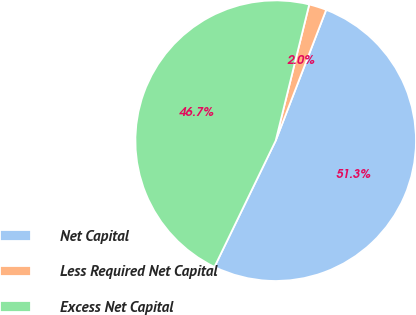Convert chart to OTSL. <chart><loc_0><loc_0><loc_500><loc_500><pie_chart><fcel>Net Capital<fcel>Less Required Net Capital<fcel>Excess Net Capital<nl><fcel>51.33%<fcel>2.02%<fcel>46.66%<nl></chart> 